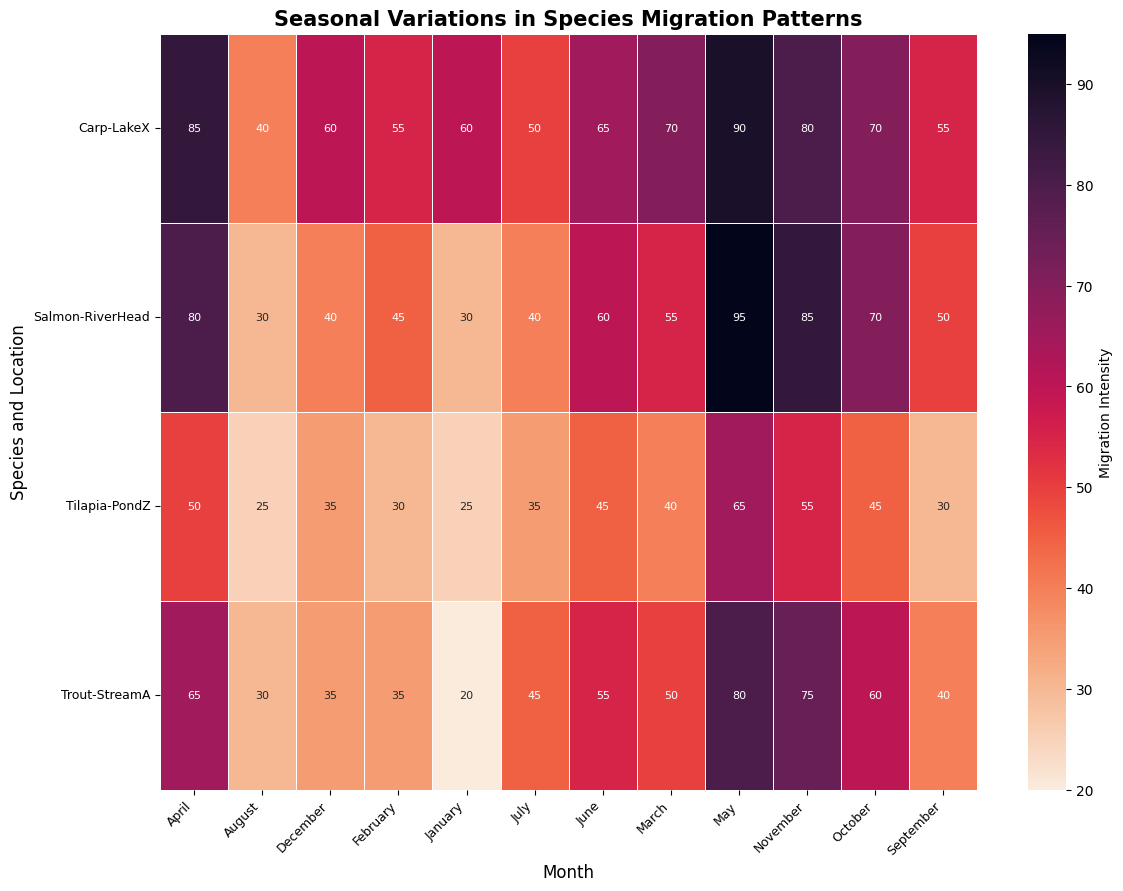How does the migration intensity of Salmon in RiverHead compare between January and July? In January, the migration intensity of Salmon in RiverHead is 30, whereas in July, it is 40. Since 40 is greater than 30, the migration intensity is higher in July.
Answer: Higher in July What is the sum of the migration intensities of Carp in LakeX for the months of March, April, and May? To find the sum, we add the migration intensities for March (70), April (85), and May (90). The sum is 70 + 85 + 90 = 245.
Answer: 245 Which species and location combination has the highest migration intensity in November? By looking at the heatmap, we find the highest intensity value in November. Carp in LakeX shows the highest migration intensity with a value of 80.
Answer: Carp in LakeX What is the average migration intensity of Trout in StreamA across the summer months (June, July, and August)? To find the average, sum the intensities for June (55), July (45), and August (30), which gives a total of 130. Divide by the number of months (3) to get 130 / 3 ≈ 43.33.
Answer: 43.33 Did Tilapia in PondZ exhibit an increase or decrease in migration intensity from August to November? In August, the migration intensity of Tilapia in PondZ is 25, and in November, it is 55. Since 55 is greater than 25, the migration intensity increased.
Answer: Increase What is the difference in migration intensity of Salmon at RiverHead between the peak month and the month with the lowest intensity? The peak month for Salmon in RiverHead is May (95), and the lowest month is January and August (both 30). The difference is 95 - 30 = 65.
Answer: 65 Which species and location show the least variation in migration intensity throughout the year? By observing the heatmap, Tilapia in PondZ shows relatively less variation in migration intensity, ranging between 25 and 65.
Answer: Tilapia in PondZ How does the migration intensity of Carp in LakeX in December compare to the yearly average for the same species and location? First, find the yearly average for Carp in LakeX: (60+55+70+85+90+65+50+40+55+70+80+60)/12 = 61.25. In December, the intensity is 60, which is slightly below the yearly average of 61.25.
Answer: Below average By how much does the migration intensity of Trout in StreamA in November exceed the intensity in January? The migration intensity of Trout in StreamA in January is 20, and in November, it is 75. The difference is 75 - 20 = 55.
Answer: 55 